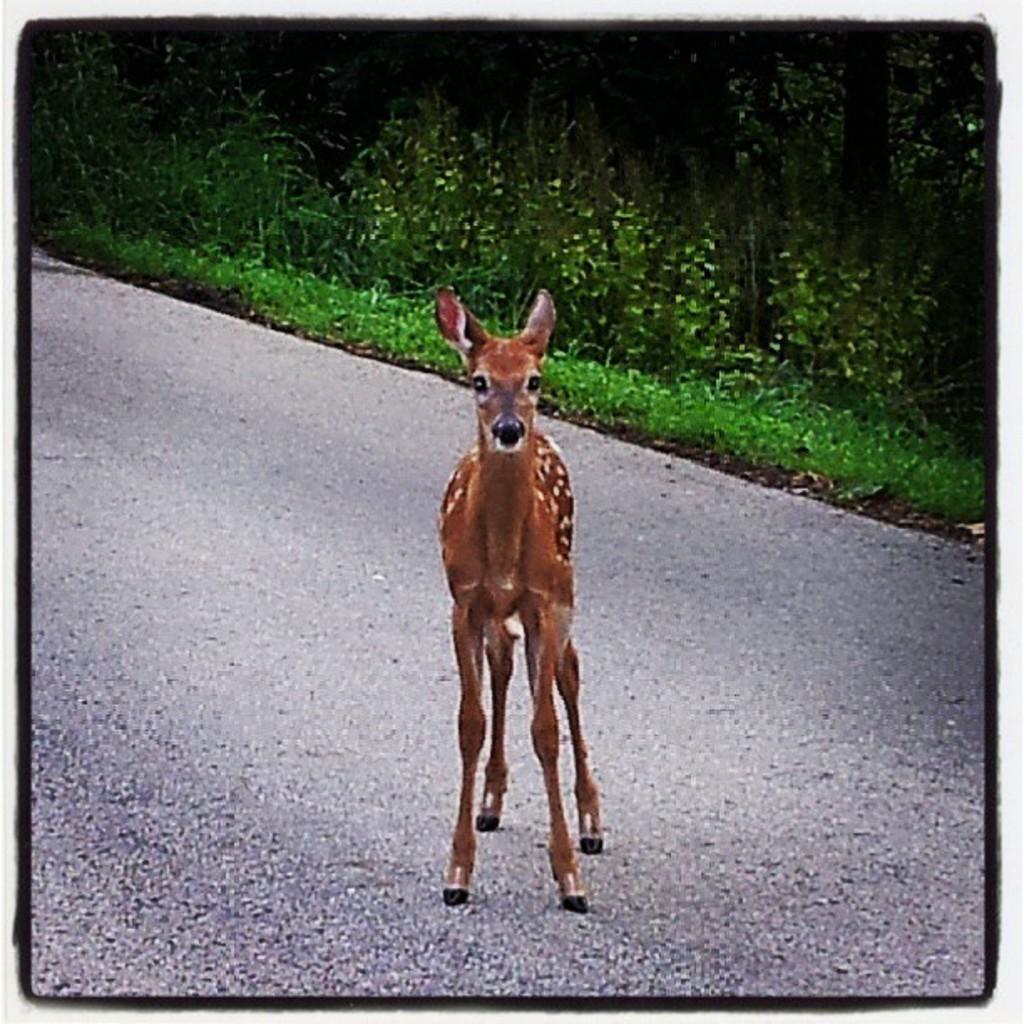In one or two sentences, can you explain what this image depicts? In this image we can see a photo. In the photo there is an animal on the road. Behind the animal we can see the grass, plants and the trees. 